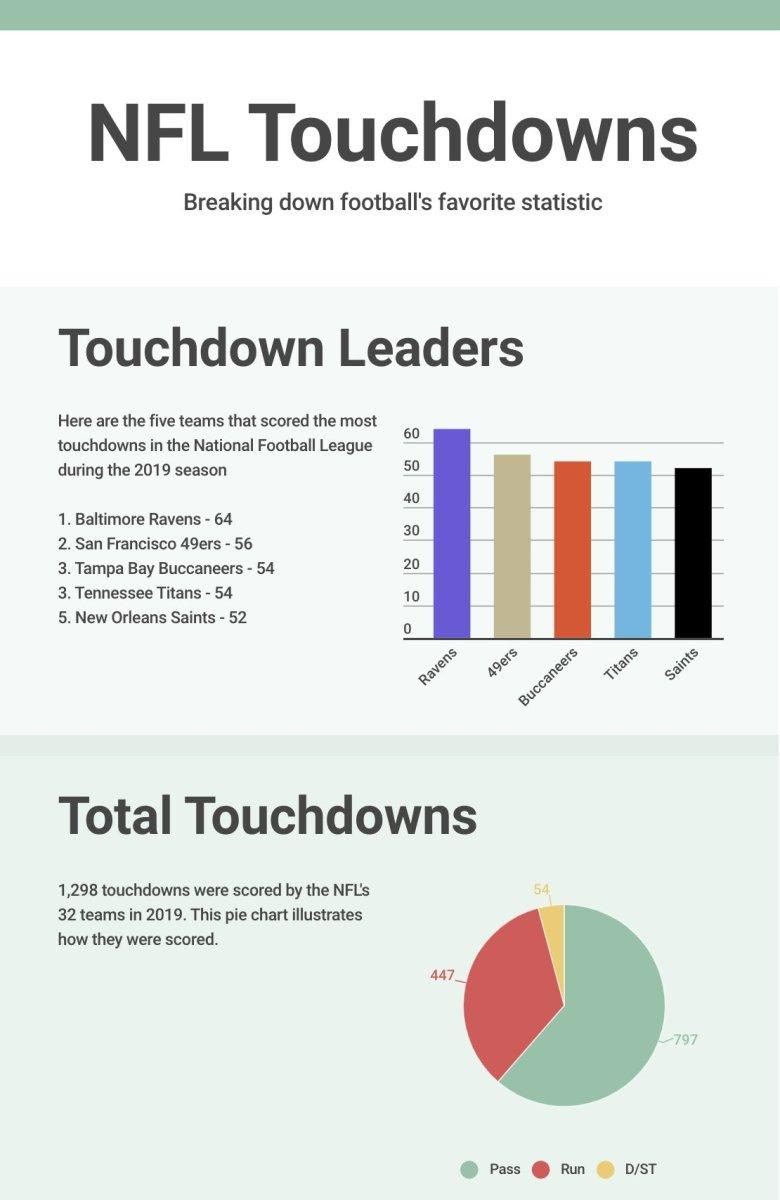Point out several critical features in this image. The San Francisco 49ers are the NFL team that has scored the second-highest number of touchdowns during the 2019 season. In 2019, the total number of passes made by the NFL's 32 teams was 797. The grand total of runs scored by the National Football League's 32 teams in 2019 was 447. During the 2019 season, the Baltimore Ravens scored 64 touchdowns. 